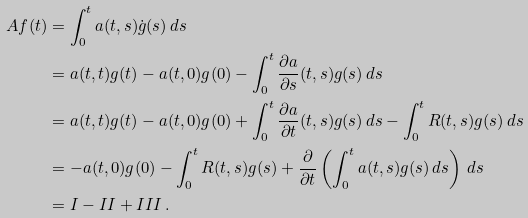<formula> <loc_0><loc_0><loc_500><loc_500>A f ( t ) & = \int _ { 0 } ^ { t } a ( t , s ) \dot { g } ( s ) \, d s \\ & = a ( t , t ) g ( t ) - a ( t , 0 ) g ( 0 ) - \int _ { 0 } ^ { t } \frac { \partial a } { \partial s } ( t , s ) g ( s ) \, d s \\ & = a ( t , t ) g ( t ) - a ( t , 0 ) g ( 0 ) + \int _ { 0 } ^ { t } \frac { \partial a } { \partial t } ( t , s ) g ( s ) \, d s - \int _ { 0 } ^ { t } R ( t , s ) g ( s ) \, d s \\ & = - a ( t , 0 ) g ( 0 ) - \int _ { 0 } ^ { t } R ( t , s ) g ( s ) + \frac { \partial } { \partial t } \left ( \int _ { 0 } ^ { t } a ( t , s ) g ( s ) \, d s \right ) \, d s \\ & = I - I I + I I I \, .</formula> 